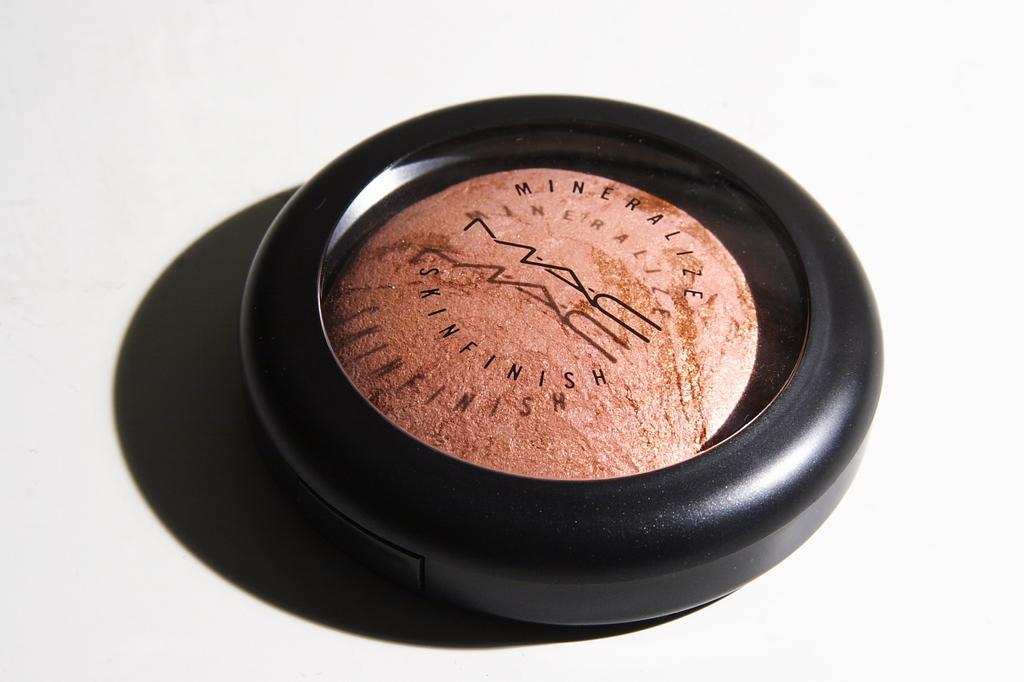<image>
Give a short and clear explanation of the subsequent image. Pod of Mineralize Skin Finish make up made by MAC. 